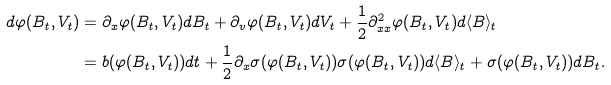Convert formula to latex. <formula><loc_0><loc_0><loc_500><loc_500>d \varphi ( B _ { t } , V _ { t } ) & = \partial _ { x } \varphi ( B _ { t } , V _ { t } ) d B _ { t } + \partial _ { v } \varphi ( B _ { t } , V _ { t } ) d V _ { t } + \frac { 1 } { 2 } \partial ^ { 2 } _ { x x } \varphi ( B _ { t } , V _ { t } ) d \langle B \rangle _ { t } \\ & = b ( \varphi ( B _ { t } , V _ { t } ) ) d t + \frac { 1 } { 2 } \partial _ { x } \sigma ( \varphi ( B _ { t } , V _ { t } ) ) \sigma ( \varphi ( B _ { t } , V _ { t } ) ) d \langle B \rangle _ { t } + \sigma ( \varphi ( B _ { t } , V _ { t } ) ) d B _ { t } .</formula> 